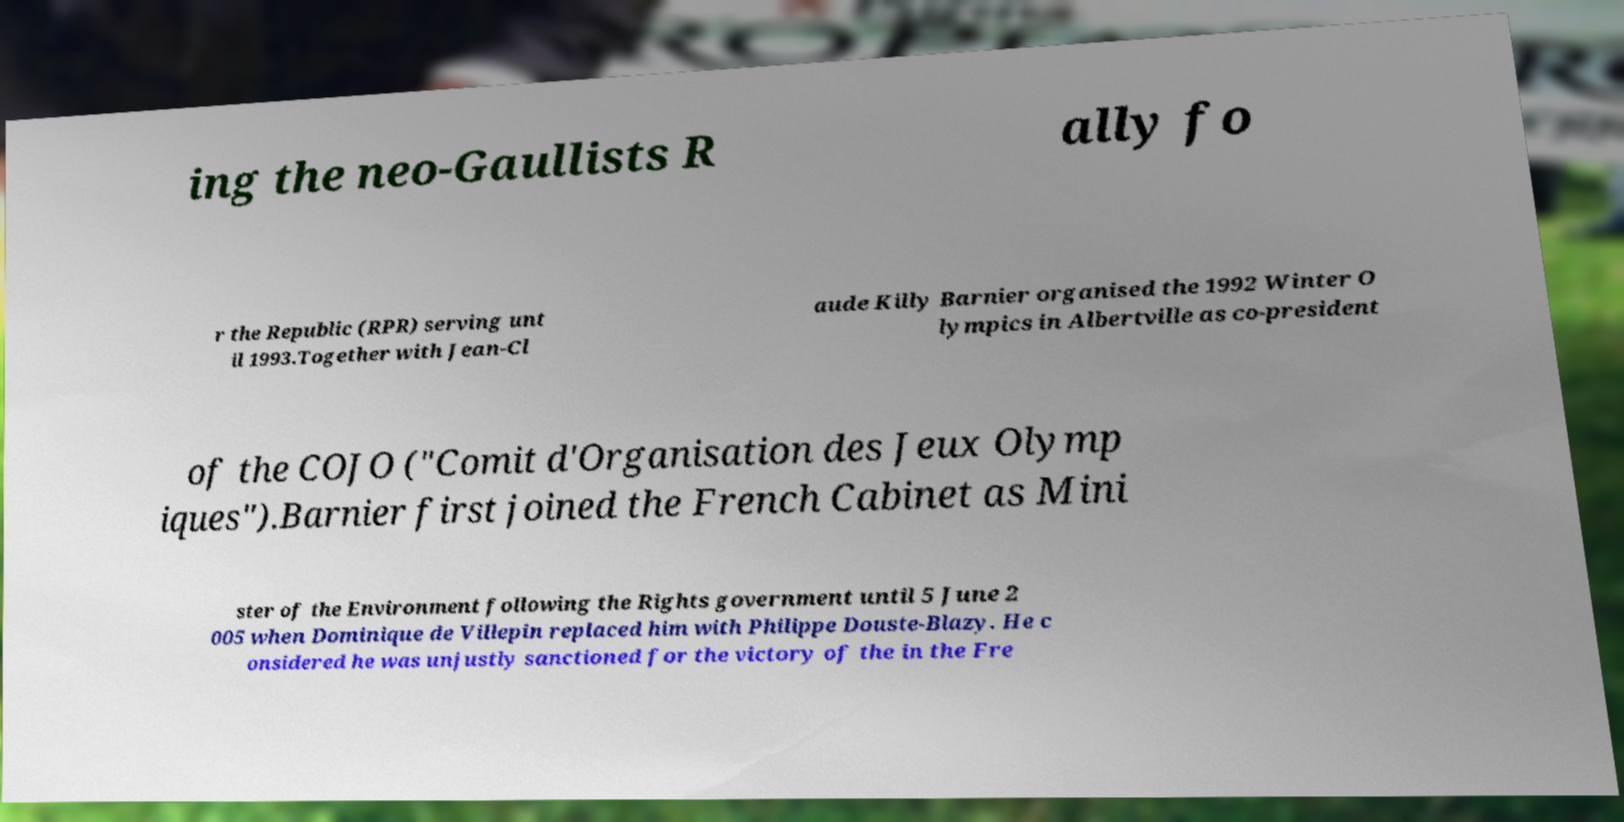What messages or text are displayed in this image? I need them in a readable, typed format. ing the neo-Gaullists R ally fo r the Republic (RPR) serving unt il 1993.Together with Jean-Cl aude Killy Barnier organised the 1992 Winter O lympics in Albertville as co-president of the COJO ("Comit d'Organisation des Jeux Olymp iques").Barnier first joined the French Cabinet as Mini ster of the Environment following the Rights government until 5 June 2 005 when Dominique de Villepin replaced him with Philippe Douste-Blazy. He c onsidered he was unjustly sanctioned for the victory of the in the Fre 